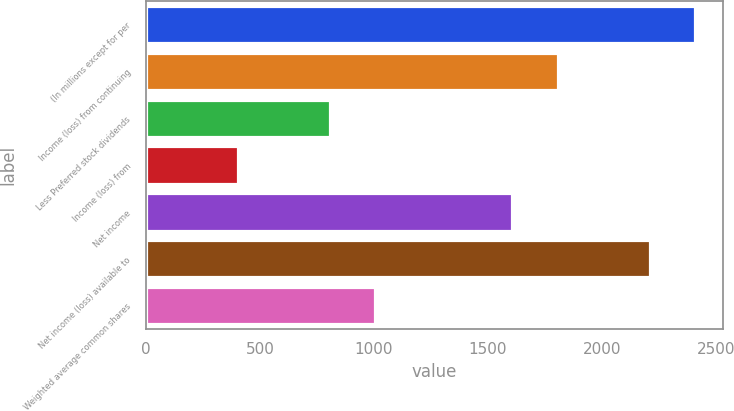<chart> <loc_0><loc_0><loc_500><loc_500><bar_chart><fcel>(In millions except for per<fcel>Income (loss) from continuing<fcel>Less Preferred stock dividends<fcel>Income (loss) from<fcel>Net income<fcel>Net income (loss) available to<fcel>Weighted average common shares<nl><fcel>2410.24<fcel>1808.41<fcel>805.36<fcel>404.14<fcel>1607.8<fcel>2209.63<fcel>1005.97<nl></chart> 